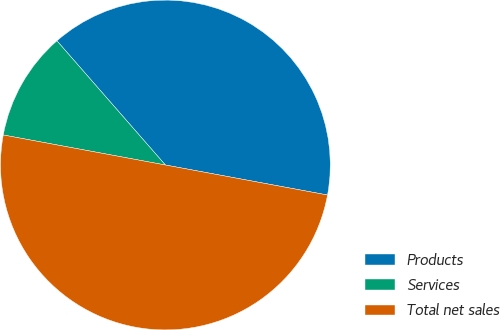Convert chart. <chart><loc_0><loc_0><loc_500><loc_500><pie_chart><fcel>Products<fcel>Services<fcel>Total net sales<nl><fcel>39.34%<fcel>10.66%<fcel>50.0%<nl></chart> 